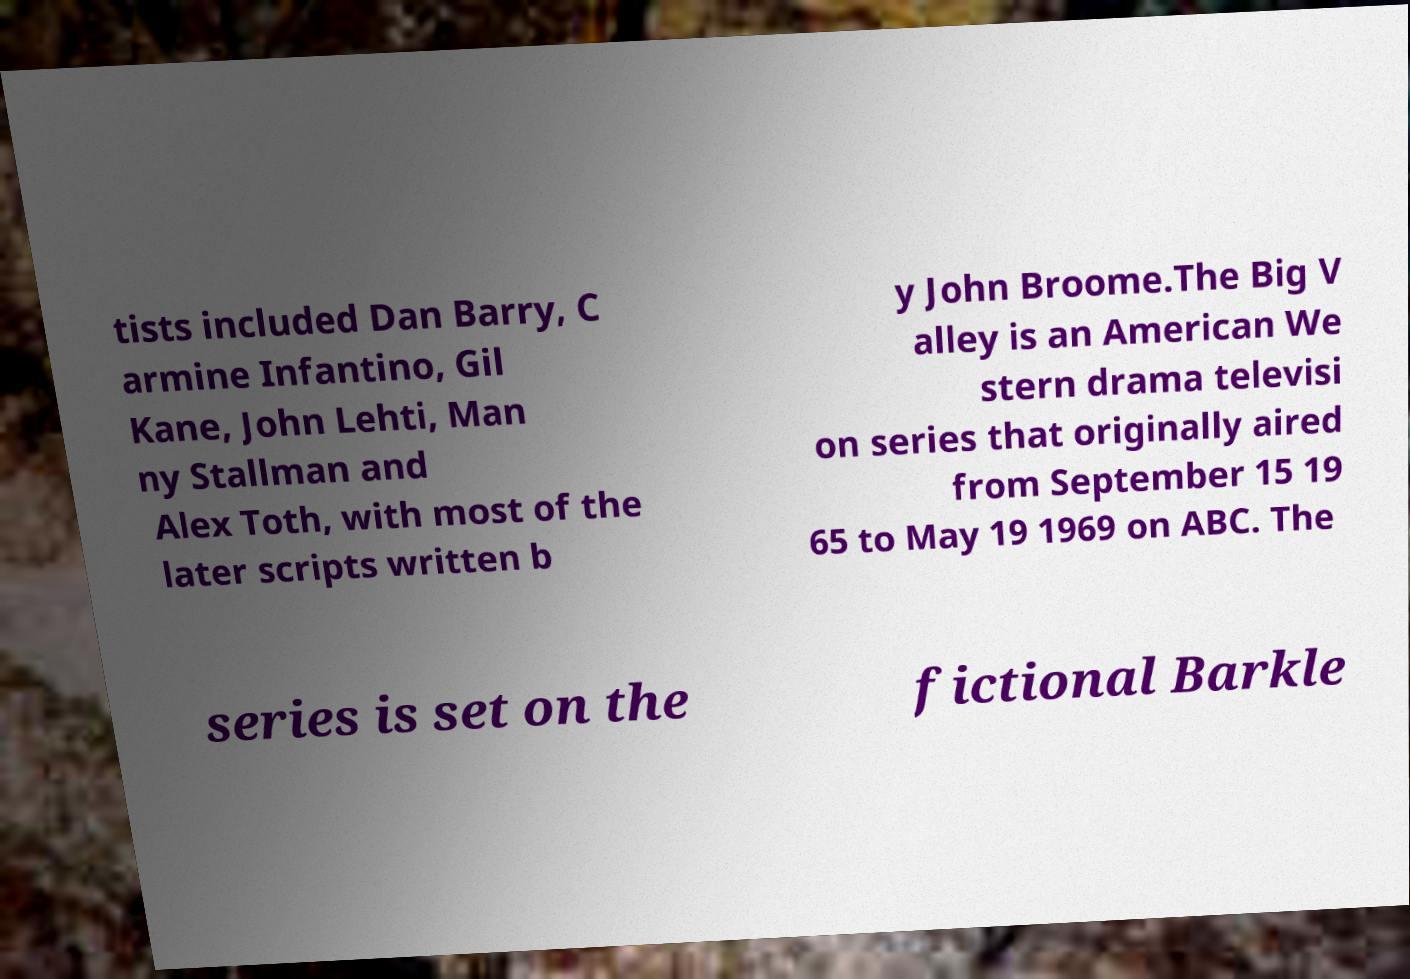What messages or text are displayed in this image? I need them in a readable, typed format. tists included Dan Barry, C armine Infantino, Gil Kane, John Lehti, Man ny Stallman and Alex Toth, with most of the later scripts written b y John Broome.The Big V alley is an American We stern drama televisi on series that originally aired from September 15 19 65 to May 19 1969 on ABC. The series is set on the fictional Barkle 